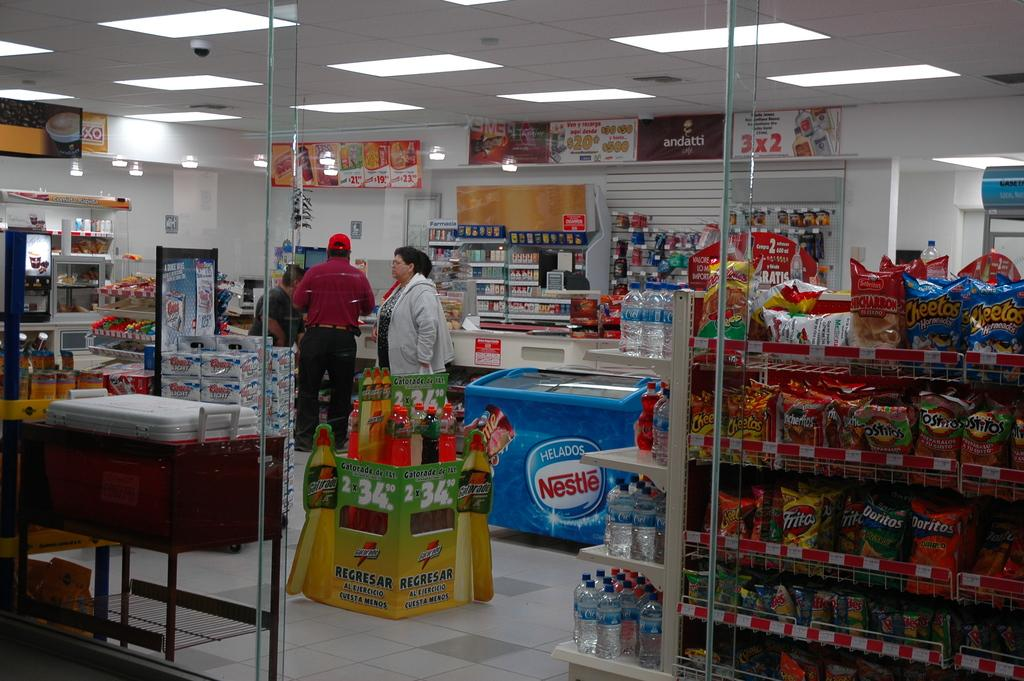<image>
Write a terse but informative summary of the picture. A store that is selling Gatorade from a green box. 